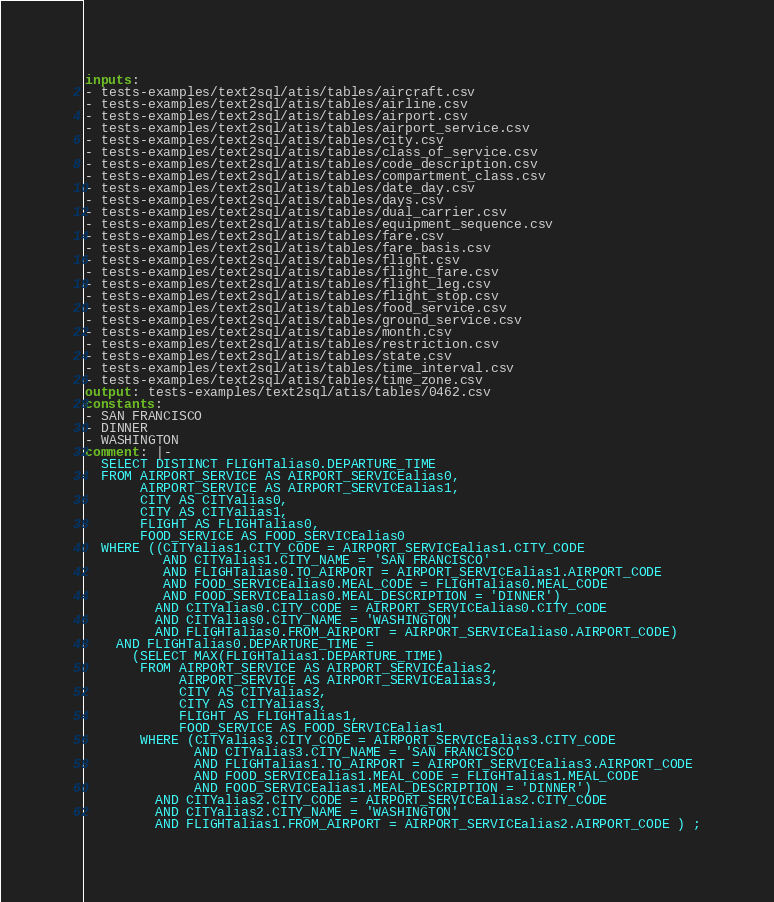<code> <loc_0><loc_0><loc_500><loc_500><_YAML_>inputs:
- tests-examples/text2sql/atis/tables/aircraft.csv
- tests-examples/text2sql/atis/tables/airline.csv
- tests-examples/text2sql/atis/tables/airport.csv
- tests-examples/text2sql/atis/tables/airport_service.csv
- tests-examples/text2sql/atis/tables/city.csv
- tests-examples/text2sql/atis/tables/class_of_service.csv
- tests-examples/text2sql/atis/tables/code_description.csv
- tests-examples/text2sql/atis/tables/compartment_class.csv
- tests-examples/text2sql/atis/tables/date_day.csv
- tests-examples/text2sql/atis/tables/days.csv
- tests-examples/text2sql/atis/tables/dual_carrier.csv
- tests-examples/text2sql/atis/tables/equipment_sequence.csv
- tests-examples/text2sql/atis/tables/fare.csv
- tests-examples/text2sql/atis/tables/fare_basis.csv
- tests-examples/text2sql/atis/tables/flight.csv
- tests-examples/text2sql/atis/tables/flight_fare.csv
- tests-examples/text2sql/atis/tables/flight_leg.csv
- tests-examples/text2sql/atis/tables/flight_stop.csv
- tests-examples/text2sql/atis/tables/food_service.csv
- tests-examples/text2sql/atis/tables/ground_service.csv
- tests-examples/text2sql/atis/tables/month.csv
- tests-examples/text2sql/atis/tables/restriction.csv
- tests-examples/text2sql/atis/tables/state.csv
- tests-examples/text2sql/atis/tables/time_interval.csv
- tests-examples/text2sql/atis/tables/time_zone.csv
output: tests-examples/text2sql/atis/tables/0462.csv
constants:
- SAN FRANCISCO
- DINNER
- WASHINGTON
comment: |-
  SELECT DISTINCT FLIGHTalias0.DEPARTURE_TIME
  FROM AIRPORT_SERVICE AS AIRPORT_SERVICEalias0,
       AIRPORT_SERVICE AS AIRPORT_SERVICEalias1,
       CITY AS CITYalias0,
       CITY AS CITYalias1,
       FLIGHT AS FLIGHTalias0,
       FOOD_SERVICE AS FOOD_SERVICEalias0
  WHERE ((CITYalias1.CITY_CODE = AIRPORT_SERVICEalias1.CITY_CODE
          AND CITYalias1.CITY_NAME = 'SAN FRANCISCO'
          AND FLIGHTalias0.TO_AIRPORT = AIRPORT_SERVICEalias1.AIRPORT_CODE
          AND FOOD_SERVICEalias0.MEAL_CODE = FLIGHTalias0.MEAL_CODE
          AND FOOD_SERVICEalias0.MEAL_DESCRIPTION = 'DINNER')
         AND CITYalias0.CITY_CODE = AIRPORT_SERVICEalias0.CITY_CODE
         AND CITYalias0.CITY_NAME = 'WASHINGTON'
         AND FLIGHTalias0.FROM_AIRPORT = AIRPORT_SERVICEalias0.AIRPORT_CODE)
    AND FLIGHTalias0.DEPARTURE_TIME =
      (SELECT MAX(FLIGHTalias1.DEPARTURE_TIME)
       FROM AIRPORT_SERVICE AS AIRPORT_SERVICEalias2,
            AIRPORT_SERVICE AS AIRPORT_SERVICEalias3,
            CITY AS CITYalias2,
            CITY AS CITYalias3,
            FLIGHT AS FLIGHTalias1,
            FOOD_SERVICE AS FOOD_SERVICEalias1
       WHERE (CITYalias3.CITY_CODE = AIRPORT_SERVICEalias3.CITY_CODE
              AND CITYalias3.CITY_NAME = 'SAN FRANCISCO'
              AND FLIGHTalias1.TO_AIRPORT = AIRPORT_SERVICEalias3.AIRPORT_CODE
              AND FOOD_SERVICEalias1.MEAL_CODE = FLIGHTalias1.MEAL_CODE
              AND FOOD_SERVICEalias1.MEAL_DESCRIPTION = 'DINNER')
         AND CITYalias2.CITY_CODE = AIRPORT_SERVICEalias2.CITY_CODE
         AND CITYalias2.CITY_NAME = 'WASHINGTON'
         AND FLIGHTalias1.FROM_AIRPORT = AIRPORT_SERVICEalias2.AIRPORT_CODE ) ;
</code> 